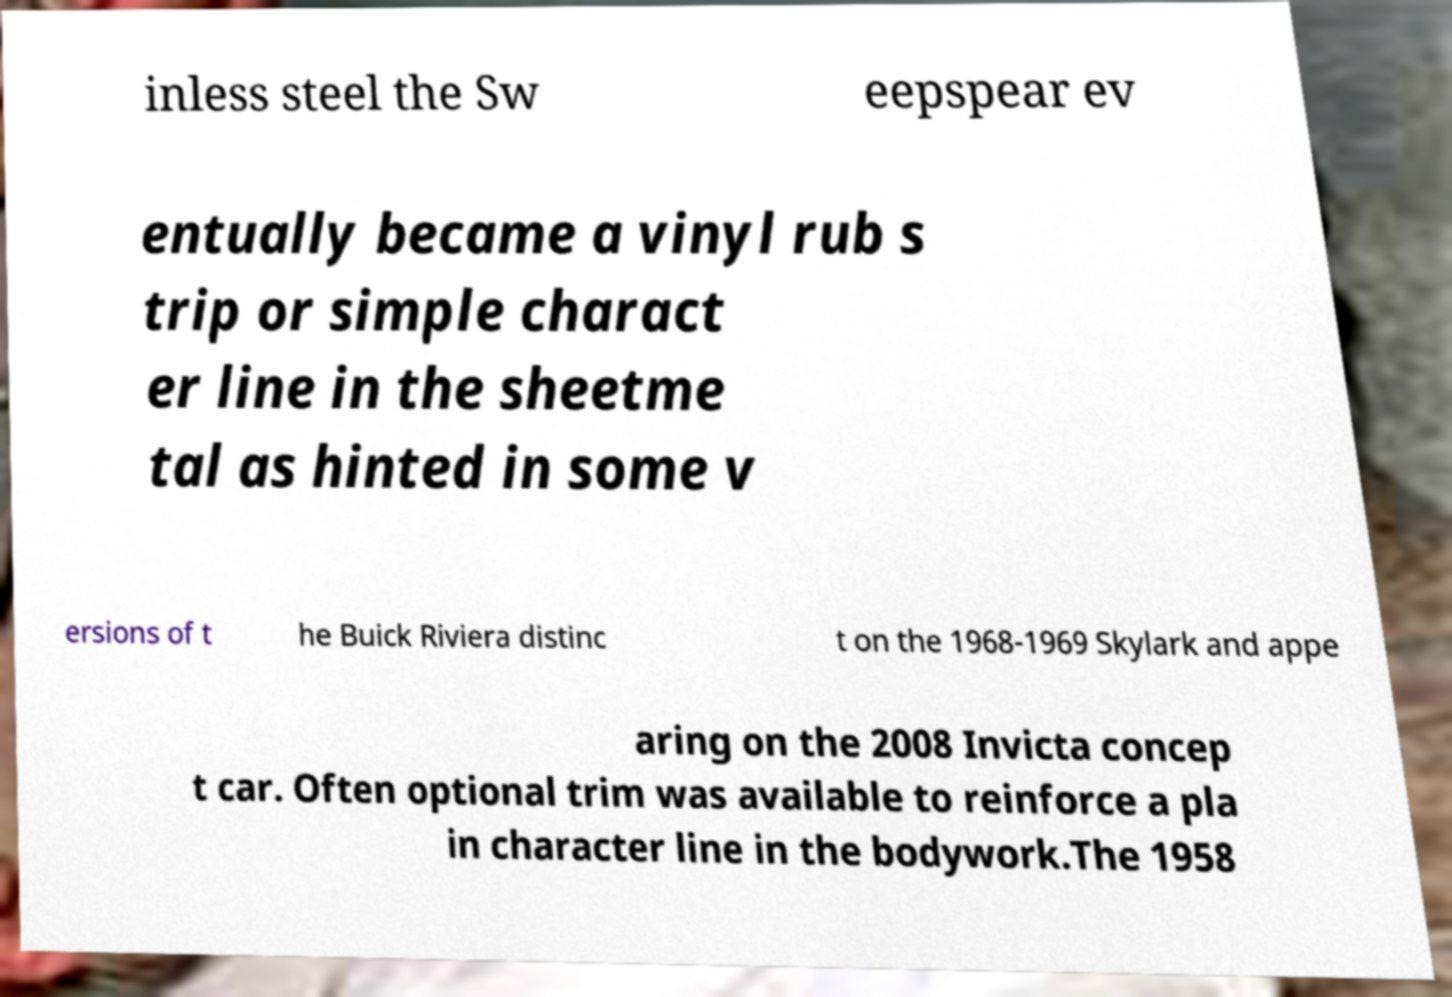There's text embedded in this image that I need extracted. Can you transcribe it verbatim? inless steel the Sw eepspear ev entually became a vinyl rub s trip or simple charact er line in the sheetme tal as hinted in some v ersions of t he Buick Riviera distinc t on the 1968-1969 Skylark and appe aring on the 2008 Invicta concep t car. Often optional trim was available to reinforce a pla in character line in the bodywork.The 1958 